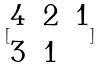<formula> <loc_0><loc_0><loc_500><loc_500>[ \begin{matrix} 4 & 2 & 1 \\ 3 & 1 \end{matrix} ]</formula> 